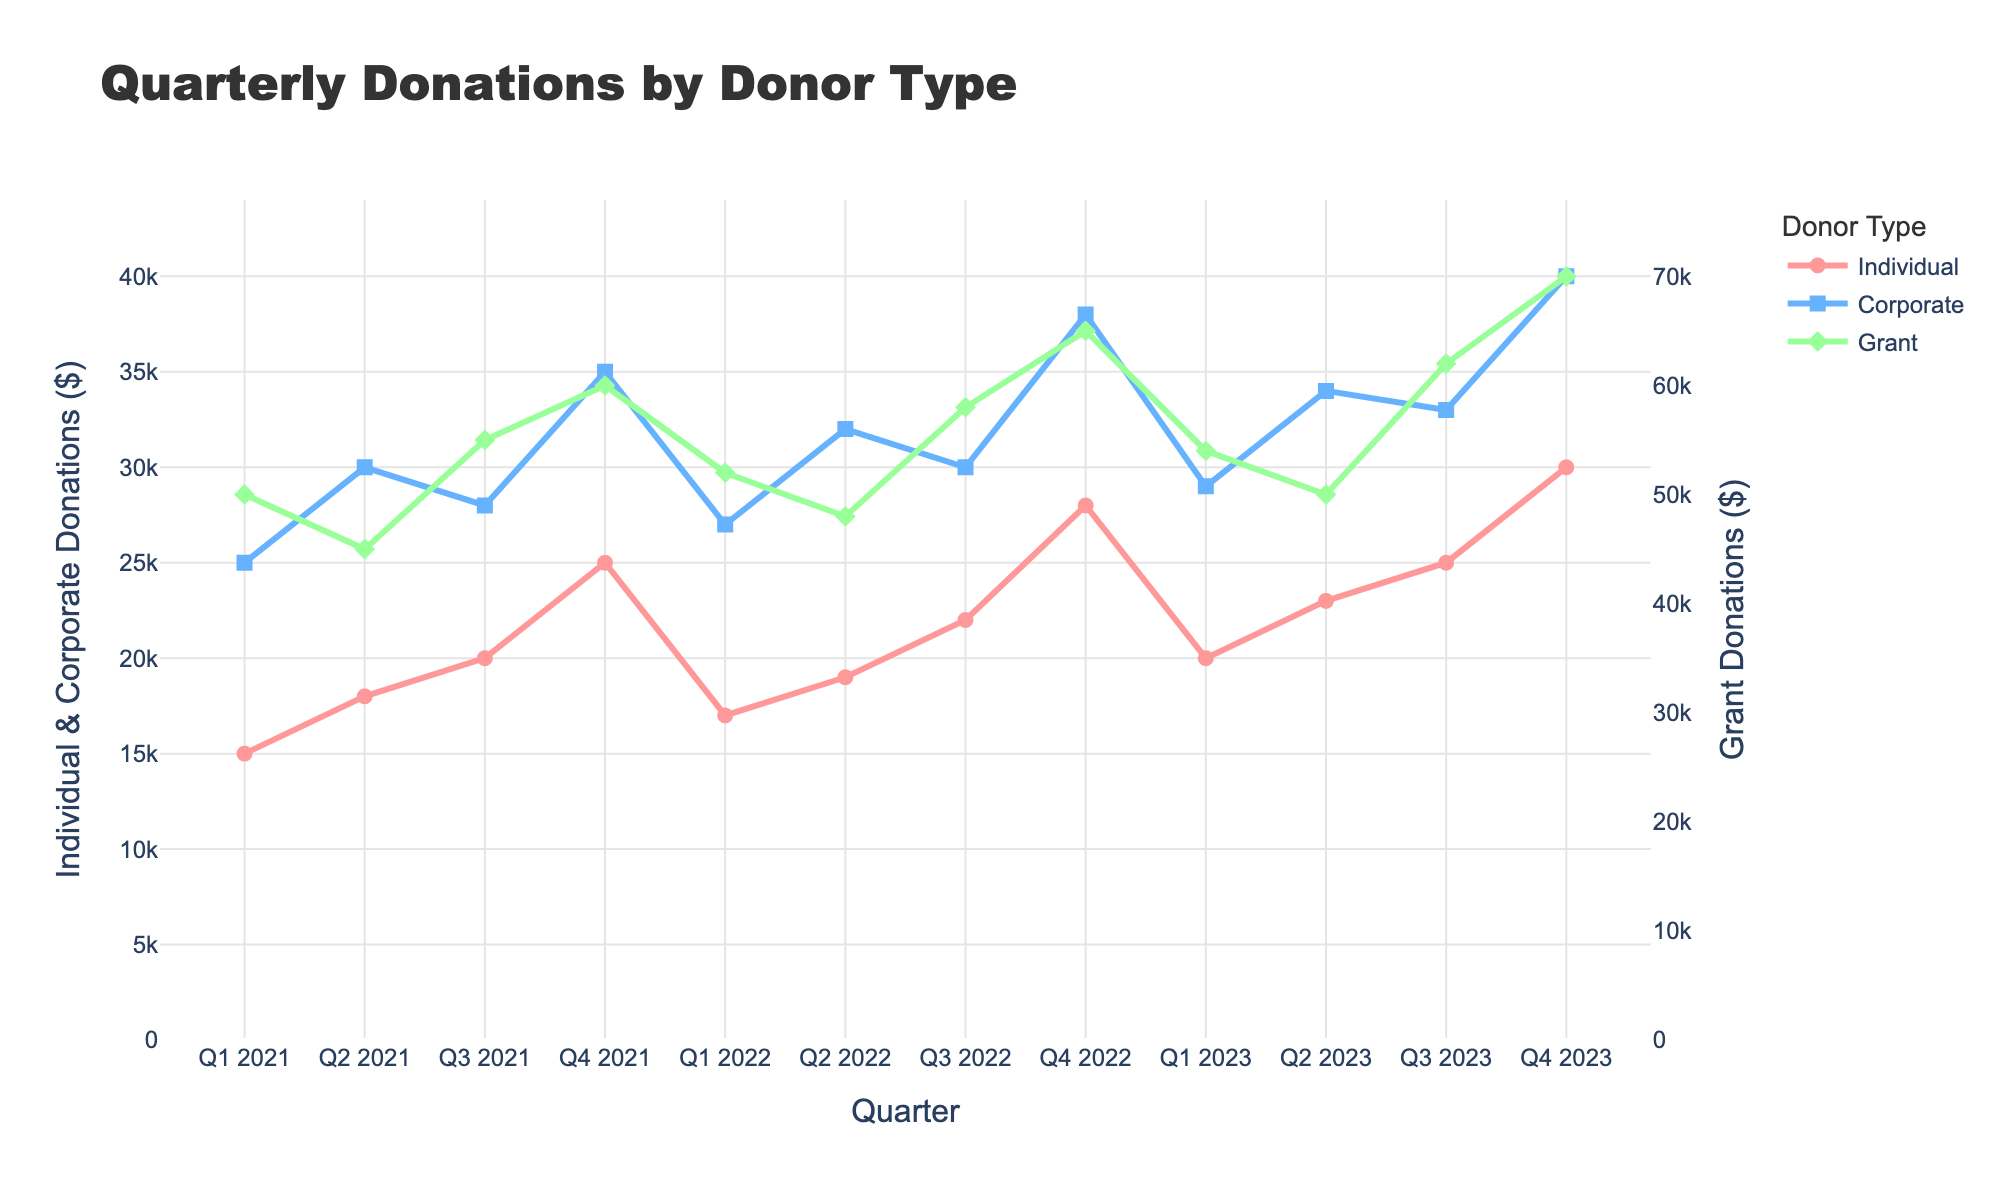Which quarter had the highest total donations from all donor types? To find this, we sum the donations from Individual, Corporate, and Grant for each quarter and compare them. For Q4 2023, the total is (30000 + 40000 + 70000) = 140000, which is the highest.
Answer: Q4 2023 Between which consecutive quarters did Individual donations decrease the most? To determine this, we calculate the difference in Individual donations between each consecutive quarter. The largest decrease is between Q4 2021 and Q1 2022: 25000 - 17000 = 8000.
Answer: Q4 2021 to Q1 2022 Which donor type showed the most consistent increase in donations over the time period? By observing the lines, we notice that Grant donations have consistently increased each quarter, unlike the fluctuating patterns of Individual and Corporate donations.
Answer: Grant What is the difference between Corporate and Grant donations in Q4 2022? From the data, Corporate donations in Q4 2022 are 38000, and Grant donations are 65000. The difference is 65000 - 38000 = 27000.
Answer: 27000 What is the average donation from Individuals across all quarters? Sum the Individual donations across all quarters and divide by the number of quarters: (15000 + 18000 + 20000 + 25000 + 17000 + 19000 + 22000 + 28000 + 20000 + 23000 + 25000 + 30000) / 12 = 21833.33.
Answer: 21833.33 Which donor type had the largest donation amount in Q1 2022? In Q1 2022, the donations are 17000 (Individual), 27000 (Corporate), and 52000 (Grant). The largest is the Grant donation of 52000.
Answer: Grant How did the Corporate donations change from Q4 2022 to Q1 2023? Corporate donations in Q4 2022 were 38000, while in Q1 2023 they were 29000. The change is 29000 - 38000 = -9000, indicating a decrease.
Answer: Decreased by 9000 Which quarter saw the largest increase in total donations compared to the previous quarter? Calculate the total donations for each quarter, then find the differences between consecutive quarters. The largest increase is from Q4 2022 to Q4 2023: (30000 + 40000 + 70000) - (28000 + 38000 + 65000) = 11000.
Answer: Q4 2022 to Q4 2023 Was there any quarter where both Individual and Corporate donations increased compared to the previous quarter? Compare Individual and Corporate donations for each quarter. For example, from Q1 2021 to Q2 2021, both increased (15000 to 18000 and 25000 to 30000, respectively).
Answer: Q2 2021 